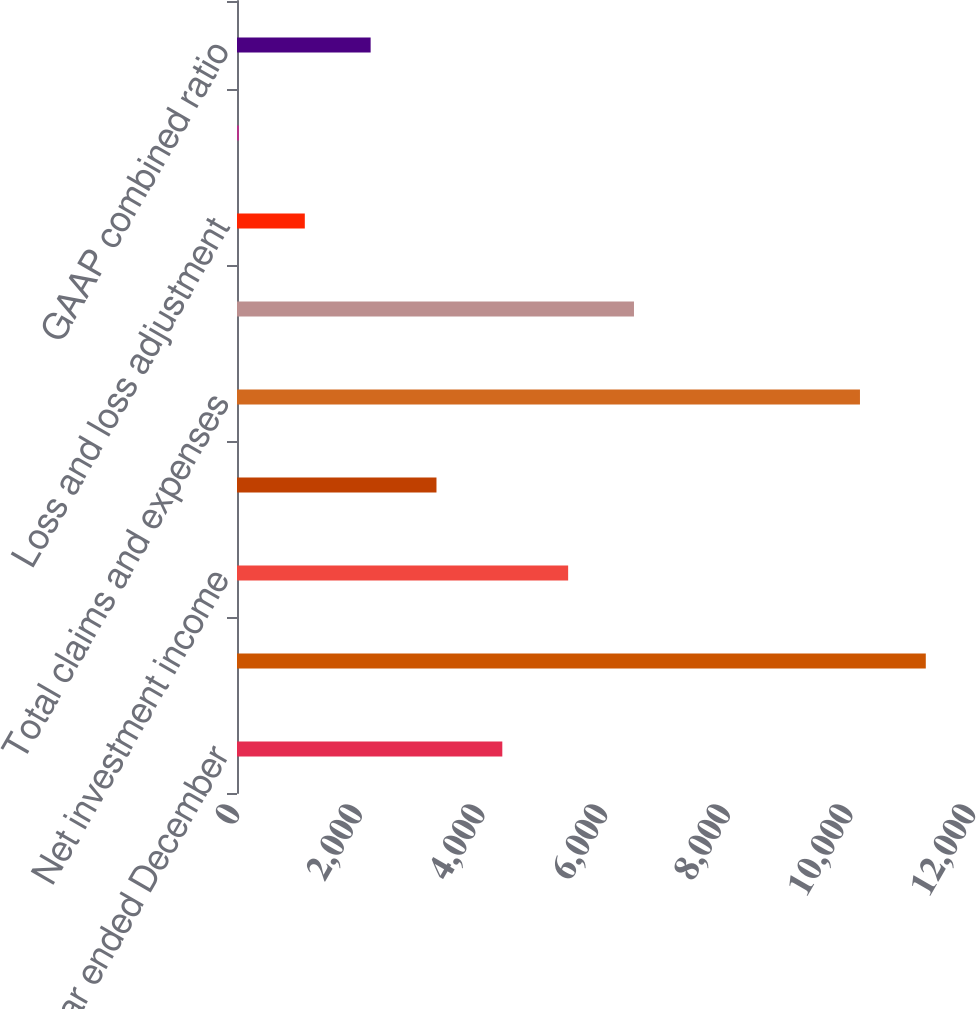Convert chart. <chart><loc_0><loc_0><loc_500><loc_500><bar_chart><fcel>(for the year ended December<fcel>Earned premiums<fcel>Net investment income<fcel>Fee income<fcel>Total claims and expenses<fcel>Operating income<fcel>Loss and loss adjustment<fcel>Underwriting expense ratio<fcel>GAAP combined ratio<nl><fcel>4325.72<fcel>11230.4<fcel>5399.1<fcel>3252.34<fcel>10157<fcel>6472.48<fcel>1105.58<fcel>32.2<fcel>2178.96<nl></chart> 